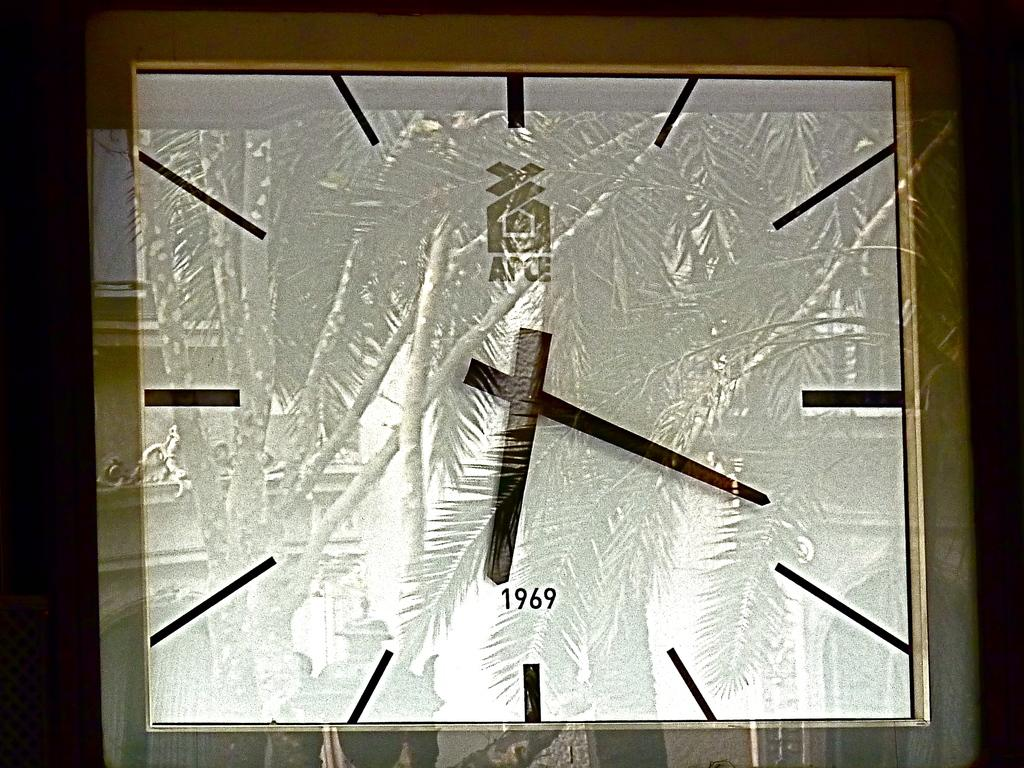Provide a one-sentence caption for the provided image. A photo of an APCE analog clock with 1969 on it. 